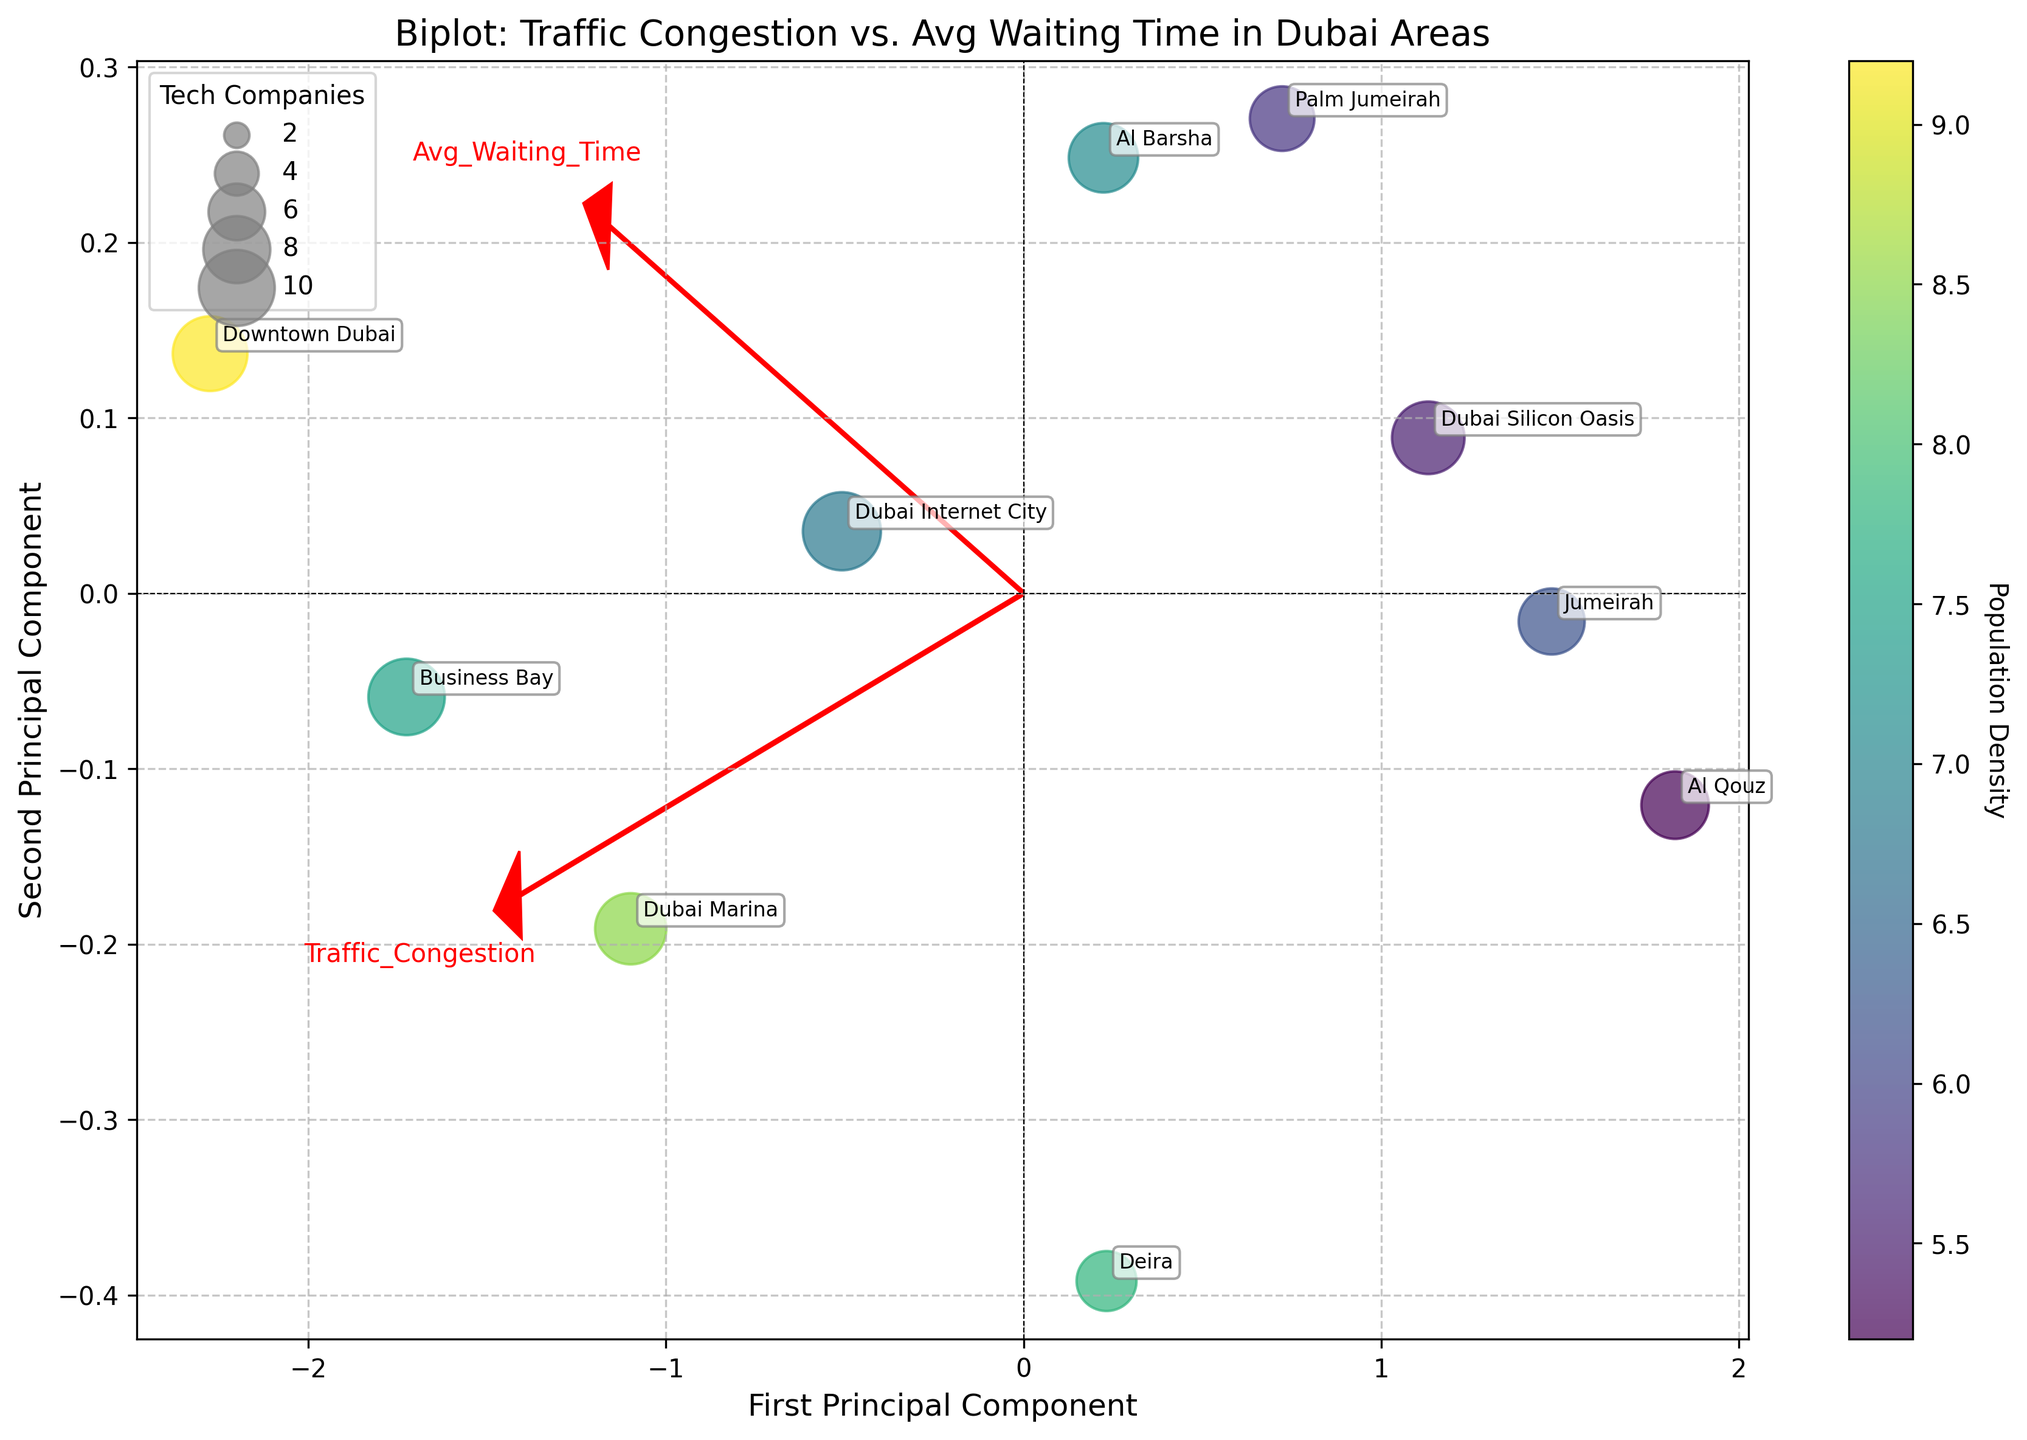What text and colors represent the variables in the biplot? The biplot uses red arrows and text to represent the variables. Specifically, "Traffic Congestion" and "Avg Waiting Time" are depicted with red arrows pointing out from the origin.
Answer: red arrows and text How is population density visualized in the plot? Population density is represented by the color of the data points. A colorbar labeled "Population Density" is included, which helps associate colors with specific density values.
Answer: colors of the data points Which variable contributes the most to the first principal component? The direction and length of the red arrows indicate the contribution of each variable to the principal components. The arrow for "Traffic Congestion" appears to align more with the first principal component axis, suggesting it contributes more to it than "Avg Waiting Time."
Answer: Traffic Congestion What does the size of each data point represent? The size of each data point is indicative of the number of tech companies in each area. The legend titled "Tech Companies" shows different point sizes corresponding to the number of tech companies.
Answer: number of tech companies What area has the highest population density according to the plot? By looking at the color of the data points and the colorbar, "Downtown Dubai" appears to have the darkest shade, indicating the highest population density among the areas plotted.
Answer: Downtown Dubai Which area has the highest average waiting time for ride-hailing services? Referring to the annotated data points and their positions along the "Avg Waiting Time" axis, "Downtown Dubai" is the farthest along the axis, indicating the highest average waiting time.
Answer: Downtown Dubai Explain how "Traffic Congestion" and "Avg Waiting Time" are related based on the biplot. To understand the relationship, observe the direction of the two red arrows. Since both arrows point generally in the same direction, it suggests a positive correlation: areas with higher traffic congestion also tend to have higher average waiting times for ride-hailing services.
Answer: positive correlation Which area has the lowest traffic congestion and how can you identify it? The area "Al Qouz" is positioned closest to the origin in the direction opposite the "Traffic Congestion" vector, indicating it has the lowest traffic congestion among the areas plotted.
Answer: Al Qouz Are there any areas with both low traffic congestion and high population density? By examining the axes and colors, "Jumeirah" appears to have relatively low traffic congestion (position closer to the origin compared to other areas along the "Traffic Congestion" vector) and an intermediate shade of color indicating a high population density.
Answer: Jumeirah Compare the tech company distribution between "Business Bay" and "Dubai Marina." Looking at the sizes of the data points, "Business Bay" has a larger point size compared to "Dubai Marina," indicating that "Business Bay" has a higher number of tech companies.
Answer: Business Bay has more tech companies 